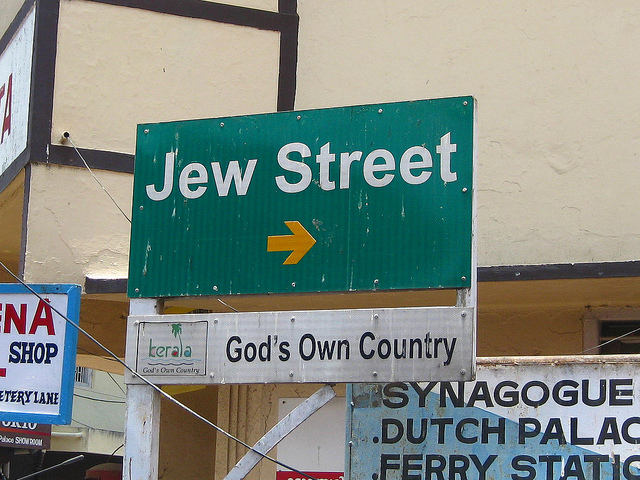Extract all visible text content from this image. Jew Street God's Own Country FERRY STATIC PALAC .DUTCH SYNAGOGUE SHOWROOM God's Own Country berala LANE ETERYI SHOP NA A 